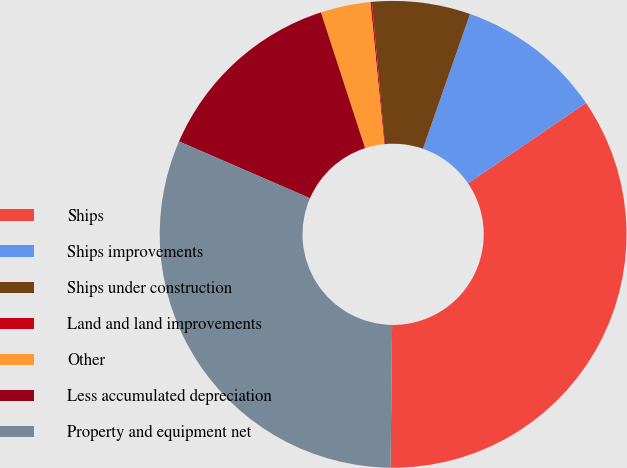Convert chart to OTSL. <chart><loc_0><loc_0><loc_500><loc_500><pie_chart><fcel>Ships<fcel>Ships improvements<fcel>Ships under construction<fcel>Land and land improvements<fcel>Other<fcel>Less accumulated depreciation<fcel>Property and equipment net<nl><fcel>34.69%<fcel>10.14%<fcel>6.79%<fcel>0.11%<fcel>3.45%<fcel>13.48%<fcel>31.34%<nl></chart> 